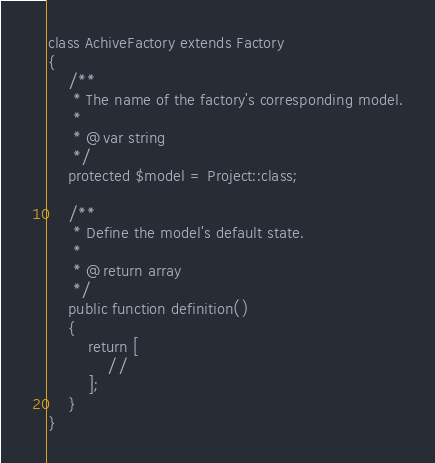<code> <loc_0><loc_0><loc_500><loc_500><_PHP_>
class AchiveFactory extends Factory
{
    /**
     * The name of the factory's corresponding model.
     *
     * @var string
     */
    protected $model = Project::class;

    /**
     * Define the model's default state.
     *
     * @return array
     */
    public function definition()
    {
        return [
            //
        ];
    }
}
</code> 